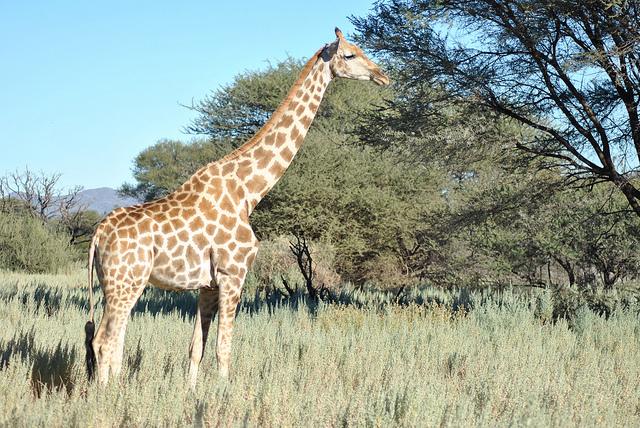Is the animal able to reach the branches on the tree?
Concise answer only. Yes. How many giraffes are in the photo?
Be succinct. 1. How many spots can you see on the animal?
Concise answer only. 100. 